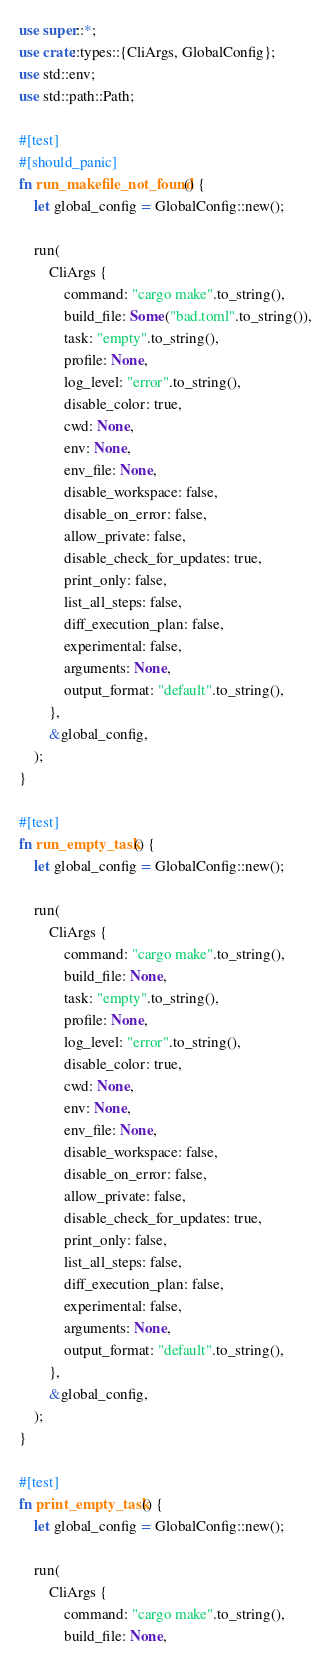Convert code to text. <code><loc_0><loc_0><loc_500><loc_500><_Rust_>use super::*;
use crate::types::{CliArgs, GlobalConfig};
use std::env;
use std::path::Path;

#[test]
#[should_panic]
fn run_makefile_not_found() {
    let global_config = GlobalConfig::new();

    run(
        CliArgs {
            command: "cargo make".to_string(),
            build_file: Some("bad.toml".to_string()),
            task: "empty".to_string(),
            profile: None,
            log_level: "error".to_string(),
            disable_color: true,
            cwd: None,
            env: None,
            env_file: None,
            disable_workspace: false,
            disable_on_error: false,
            allow_private: false,
            disable_check_for_updates: true,
            print_only: false,
            list_all_steps: false,
            diff_execution_plan: false,
            experimental: false,
            arguments: None,
            output_format: "default".to_string(),
        },
        &global_config,
    );
}

#[test]
fn run_empty_task() {
    let global_config = GlobalConfig::new();

    run(
        CliArgs {
            command: "cargo make".to_string(),
            build_file: None,
            task: "empty".to_string(),
            profile: None,
            log_level: "error".to_string(),
            disable_color: true,
            cwd: None,
            env: None,
            env_file: None,
            disable_workspace: false,
            disable_on_error: false,
            allow_private: false,
            disable_check_for_updates: true,
            print_only: false,
            list_all_steps: false,
            diff_execution_plan: false,
            experimental: false,
            arguments: None,
            output_format: "default".to_string(),
        },
        &global_config,
    );
}

#[test]
fn print_empty_task() {
    let global_config = GlobalConfig::new();

    run(
        CliArgs {
            command: "cargo make".to_string(),
            build_file: None,</code> 